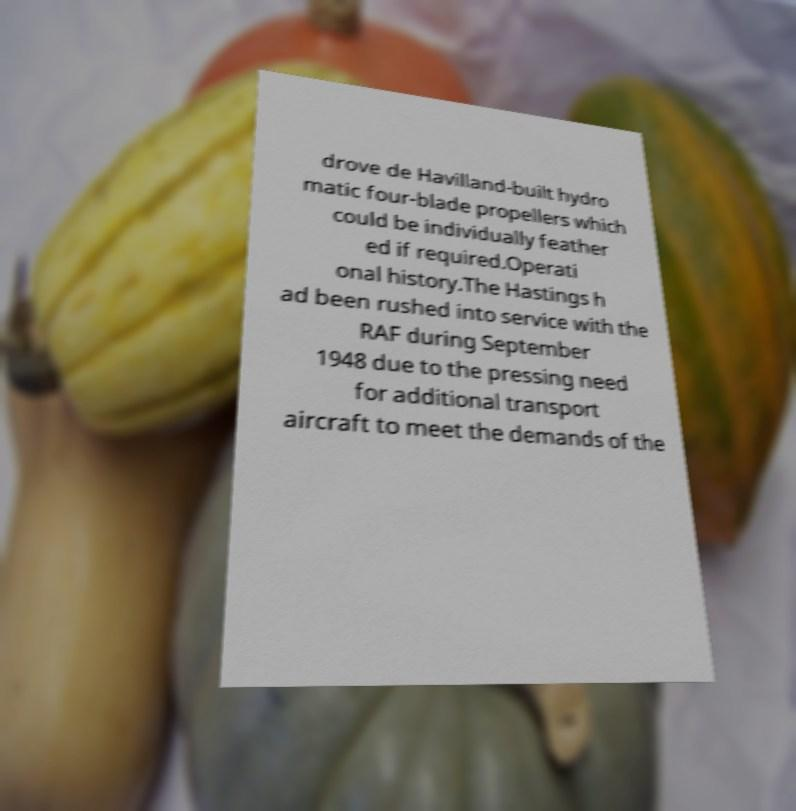Please identify and transcribe the text found in this image. drove de Havilland-built hydro matic four-blade propellers which could be individually feather ed if required.Operati onal history.The Hastings h ad been rushed into service with the RAF during September 1948 due to the pressing need for additional transport aircraft to meet the demands of the 